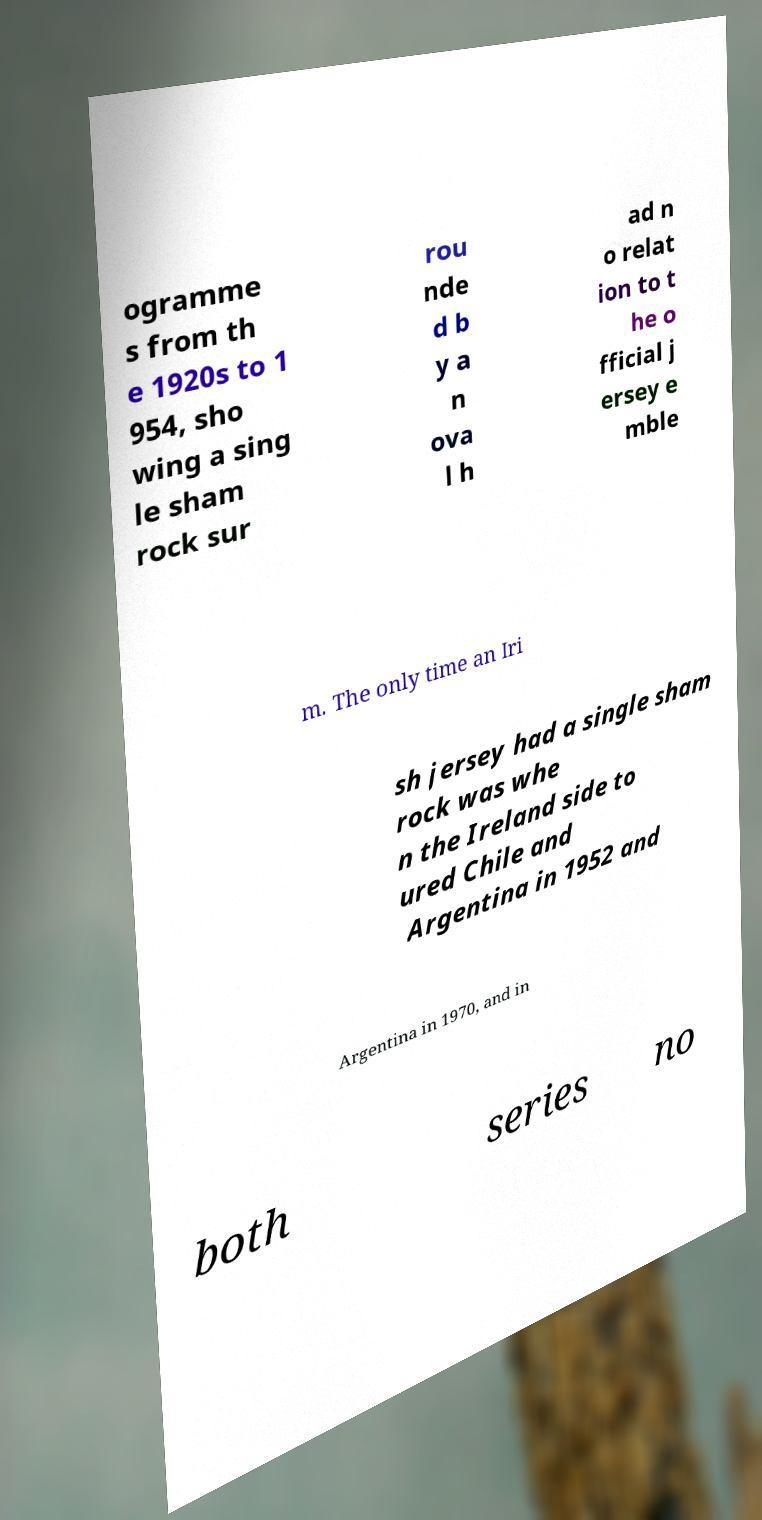What messages or text are displayed in this image? I need them in a readable, typed format. ogramme s from th e 1920s to 1 954, sho wing a sing le sham rock sur rou nde d b y a n ova l h ad n o relat ion to t he o fficial j ersey e mble m. The only time an Iri sh jersey had a single sham rock was whe n the Ireland side to ured Chile and Argentina in 1952 and Argentina in 1970, and in both series no 